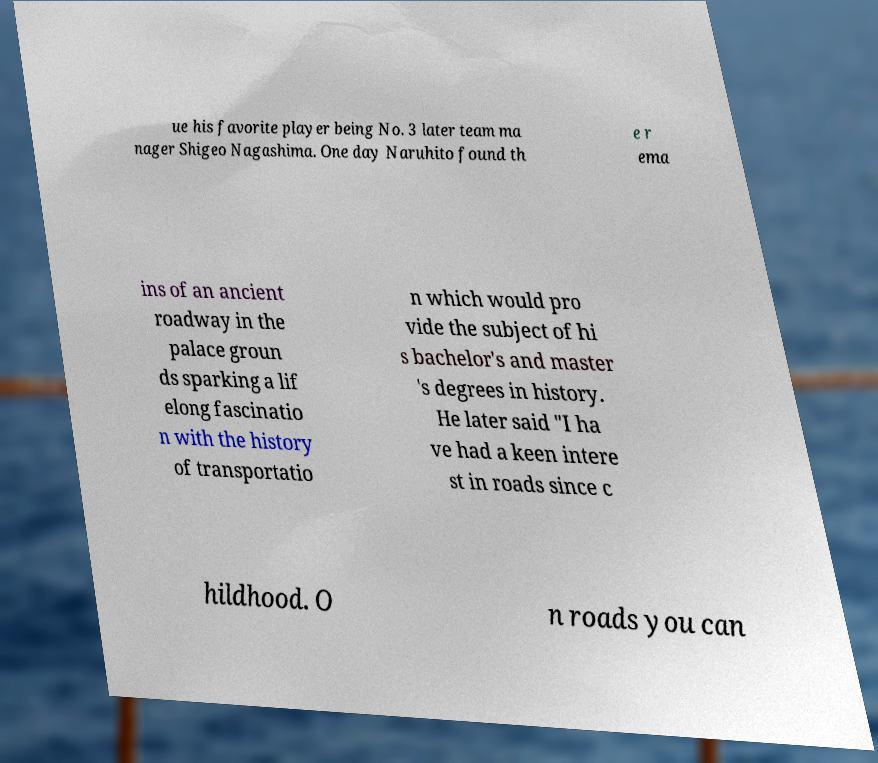Could you extract and type out the text from this image? ue his favorite player being No. 3 later team ma nager Shigeo Nagashima. One day Naruhito found th e r ema ins of an ancient roadway in the palace groun ds sparking a lif elong fascinatio n with the history of transportatio n which would pro vide the subject of hi s bachelor's and master 's degrees in history. He later said "I ha ve had a keen intere st in roads since c hildhood. O n roads you can 